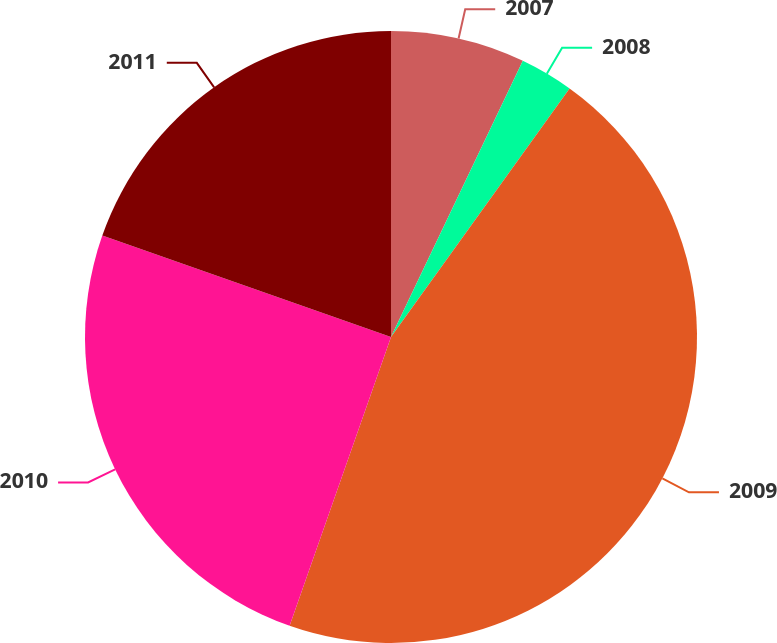Convert chart. <chart><loc_0><loc_0><loc_500><loc_500><pie_chart><fcel>2007<fcel>2008<fcel>2009<fcel>2010<fcel>2011<nl><fcel>7.09%<fcel>2.83%<fcel>45.46%<fcel>25.01%<fcel>19.62%<nl></chart> 